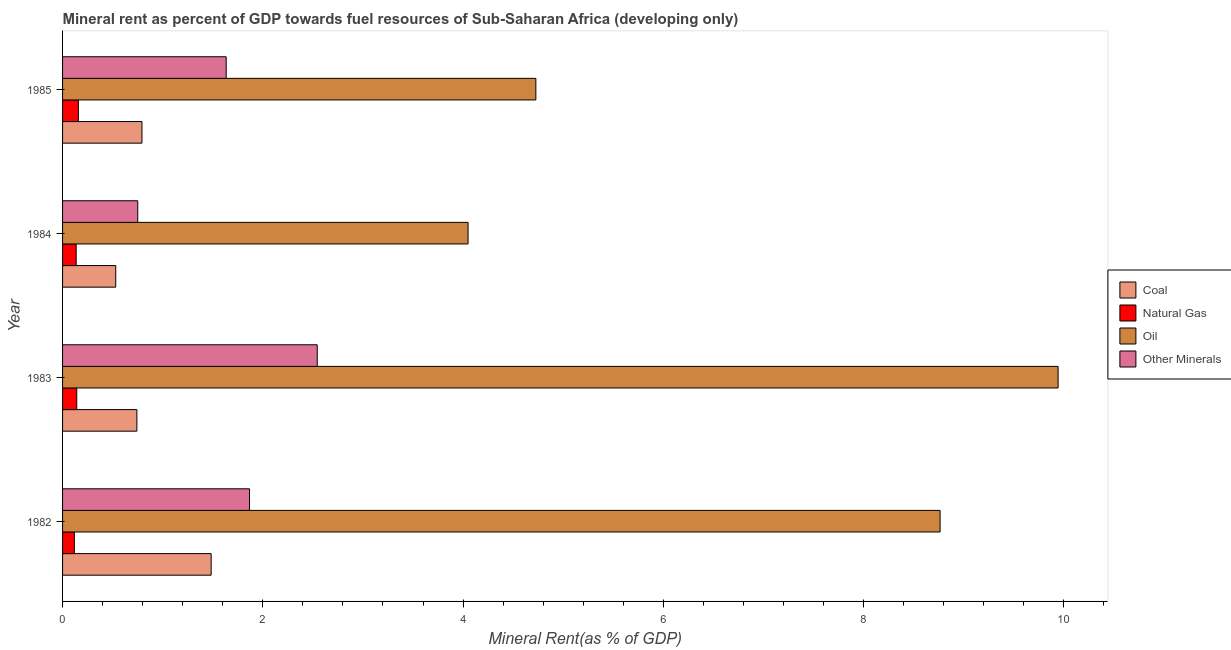How many different coloured bars are there?
Give a very brief answer. 4. How many groups of bars are there?
Offer a terse response. 4. Are the number of bars on each tick of the Y-axis equal?
Make the answer very short. Yes. How many bars are there on the 3rd tick from the top?
Offer a very short reply. 4. What is the label of the 3rd group of bars from the top?
Give a very brief answer. 1983. What is the natural gas rent in 1985?
Keep it short and to the point. 0.16. Across all years, what is the maximum natural gas rent?
Make the answer very short. 0.16. Across all years, what is the minimum  rent of other minerals?
Your answer should be very brief. 0.75. In which year was the natural gas rent maximum?
Make the answer very short. 1985. What is the total coal rent in the graph?
Make the answer very short. 3.55. What is the difference between the coal rent in 1984 and that in 1985?
Give a very brief answer. -0.26. What is the difference between the coal rent in 1985 and the  rent of other minerals in 1983?
Offer a terse response. -1.75. What is the average natural gas rent per year?
Your answer should be compact. 0.14. In the year 1985, what is the difference between the oil rent and natural gas rent?
Your answer should be compact. 4.57. In how many years, is the  rent of other minerals greater than 4 %?
Ensure brevity in your answer.  0. What is the ratio of the  rent of other minerals in 1984 to that in 1985?
Make the answer very short. 0.46. Is the oil rent in 1982 less than that in 1984?
Offer a very short reply. No. What is the difference between the highest and the second highest natural gas rent?
Give a very brief answer. 0.02. What is the difference between the highest and the lowest oil rent?
Offer a very short reply. 5.89. In how many years, is the coal rent greater than the average coal rent taken over all years?
Offer a very short reply. 1. What does the 2nd bar from the top in 1983 represents?
Provide a succinct answer. Oil. What does the 1st bar from the bottom in 1984 represents?
Provide a succinct answer. Coal. Is it the case that in every year, the sum of the coal rent and natural gas rent is greater than the oil rent?
Provide a short and direct response. No. How many years are there in the graph?
Offer a very short reply. 4. Does the graph contain any zero values?
Your answer should be very brief. No. Does the graph contain grids?
Your response must be concise. No. Where does the legend appear in the graph?
Ensure brevity in your answer.  Center right. How many legend labels are there?
Your answer should be compact. 4. What is the title of the graph?
Your answer should be compact. Mineral rent as percent of GDP towards fuel resources of Sub-Saharan Africa (developing only). Does "Oil" appear as one of the legend labels in the graph?
Your answer should be compact. Yes. What is the label or title of the X-axis?
Make the answer very short. Mineral Rent(as % of GDP). What is the Mineral Rent(as % of GDP) in Coal in 1982?
Ensure brevity in your answer.  1.48. What is the Mineral Rent(as % of GDP) in Natural Gas in 1982?
Give a very brief answer. 0.12. What is the Mineral Rent(as % of GDP) in Oil in 1982?
Provide a succinct answer. 8.76. What is the Mineral Rent(as % of GDP) in Other Minerals in 1982?
Offer a terse response. 1.87. What is the Mineral Rent(as % of GDP) of Coal in 1983?
Ensure brevity in your answer.  0.74. What is the Mineral Rent(as % of GDP) of Natural Gas in 1983?
Your response must be concise. 0.14. What is the Mineral Rent(as % of GDP) of Oil in 1983?
Give a very brief answer. 9.94. What is the Mineral Rent(as % of GDP) of Other Minerals in 1983?
Keep it short and to the point. 2.54. What is the Mineral Rent(as % of GDP) in Coal in 1984?
Offer a terse response. 0.53. What is the Mineral Rent(as % of GDP) in Natural Gas in 1984?
Make the answer very short. 0.14. What is the Mineral Rent(as % of GDP) of Oil in 1984?
Your response must be concise. 4.05. What is the Mineral Rent(as % of GDP) in Other Minerals in 1984?
Provide a succinct answer. 0.75. What is the Mineral Rent(as % of GDP) in Coal in 1985?
Make the answer very short. 0.79. What is the Mineral Rent(as % of GDP) of Natural Gas in 1985?
Your answer should be very brief. 0.16. What is the Mineral Rent(as % of GDP) of Oil in 1985?
Offer a very short reply. 4.73. What is the Mineral Rent(as % of GDP) of Other Minerals in 1985?
Your answer should be very brief. 1.63. Across all years, what is the maximum Mineral Rent(as % of GDP) of Coal?
Give a very brief answer. 1.48. Across all years, what is the maximum Mineral Rent(as % of GDP) of Natural Gas?
Offer a very short reply. 0.16. Across all years, what is the maximum Mineral Rent(as % of GDP) of Oil?
Provide a succinct answer. 9.94. Across all years, what is the maximum Mineral Rent(as % of GDP) in Other Minerals?
Offer a very short reply. 2.54. Across all years, what is the minimum Mineral Rent(as % of GDP) of Coal?
Keep it short and to the point. 0.53. Across all years, what is the minimum Mineral Rent(as % of GDP) of Natural Gas?
Offer a terse response. 0.12. Across all years, what is the minimum Mineral Rent(as % of GDP) in Oil?
Your answer should be very brief. 4.05. Across all years, what is the minimum Mineral Rent(as % of GDP) of Other Minerals?
Provide a short and direct response. 0.75. What is the total Mineral Rent(as % of GDP) of Coal in the graph?
Keep it short and to the point. 3.55. What is the total Mineral Rent(as % of GDP) in Natural Gas in the graph?
Provide a short and direct response. 0.55. What is the total Mineral Rent(as % of GDP) of Oil in the graph?
Provide a short and direct response. 27.48. What is the total Mineral Rent(as % of GDP) in Other Minerals in the graph?
Offer a terse response. 6.8. What is the difference between the Mineral Rent(as % of GDP) of Coal in 1982 and that in 1983?
Offer a terse response. 0.74. What is the difference between the Mineral Rent(as % of GDP) of Natural Gas in 1982 and that in 1983?
Your answer should be very brief. -0.02. What is the difference between the Mineral Rent(as % of GDP) of Oil in 1982 and that in 1983?
Your answer should be very brief. -1.18. What is the difference between the Mineral Rent(as % of GDP) of Other Minerals in 1982 and that in 1983?
Provide a succinct answer. -0.68. What is the difference between the Mineral Rent(as % of GDP) of Coal in 1982 and that in 1984?
Make the answer very short. 0.95. What is the difference between the Mineral Rent(as % of GDP) of Natural Gas in 1982 and that in 1984?
Your answer should be compact. -0.02. What is the difference between the Mineral Rent(as % of GDP) in Oil in 1982 and that in 1984?
Offer a very short reply. 4.71. What is the difference between the Mineral Rent(as % of GDP) in Other Minerals in 1982 and that in 1984?
Keep it short and to the point. 1.12. What is the difference between the Mineral Rent(as % of GDP) in Coal in 1982 and that in 1985?
Offer a terse response. 0.69. What is the difference between the Mineral Rent(as % of GDP) of Natural Gas in 1982 and that in 1985?
Your answer should be compact. -0.04. What is the difference between the Mineral Rent(as % of GDP) in Oil in 1982 and that in 1985?
Provide a succinct answer. 4.04. What is the difference between the Mineral Rent(as % of GDP) in Other Minerals in 1982 and that in 1985?
Provide a succinct answer. 0.23. What is the difference between the Mineral Rent(as % of GDP) in Coal in 1983 and that in 1984?
Keep it short and to the point. 0.21. What is the difference between the Mineral Rent(as % of GDP) in Natural Gas in 1983 and that in 1984?
Your answer should be compact. 0.01. What is the difference between the Mineral Rent(as % of GDP) of Oil in 1983 and that in 1984?
Make the answer very short. 5.89. What is the difference between the Mineral Rent(as % of GDP) in Other Minerals in 1983 and that in 1984?
Keep it short and to the point. 1.79. What is the difference between the Mineral Rent(as % of GDP) of Coal in 1983 and that in 1985?
Ensure brevity in your answer.  -0.05. What is the difference between the Mineral Rent(as % of GDP) in Natural Gas in 1983 and that in 1985?
Your answer should be compact. -0.02. What is the difference between the Mineral Rent(as % of GDP) of Oil in 1983 and that in 1985?
Make the answer very short. 5.22. What is the difference between the Mineral Rent(as % of GDP) of Other Minerals in 1983 and that in 1985?
Your response must be concise. 0.91. What is the difference between the Mineral Rent(as % of GDP) of Coal in 1984 and that in 1985?
Provide a short and direct response. -0.26. What is the difference between the Mineral Rent(as % of GDP) in Natural Gas in 1984 and that in 1985?
Offer a very short reply. -0.02. What is the difference between the Mineral Rent(as % of GDP) in Oil in 1984 and that in 1985?
Give a very brief answer. -0.68. What is the difference between the Mineral Rent(as % of GDP) of Other Minerals in 1984 and that in 1985?
Ensure brevity in your answer.  -0.88. What is the difference between the Mineral Rent(as % of GDP) in Coal in 1982 and the Mineral Rent(as % of GDP) in Natural Gas in 1983?
Provide a short and direct response. 1.34. What is the difference between the Mineral Rent(as % of GDP) of Coal in 1982 and the Mineral Rent(as % of GDP) of Oil in 1983?
Ensure brevity in your answer.  -8.46. What is the difference between the Mineral Rent(as % of GDP) in Coal in 1982 and the Mineral Rent(as % of GDP) in Other Minerals in 1983?
Your answer should be very brief. -1.06. What is the difference between the Mineral Rent(as % of GDP) of Natural Gas in 1982 and the Mineral Rent(as % of GDP) of Oil in 1983?
Offer a terse response. -9.82. What is the difference between the Mineral Rent(as % of GDP) in Natural Gas in 1982 and the Mineral Rent(as % of GDP) in Other Minerals in 1983?
Offer a terse response. -2.43. What is the difference between the Mineral Rent(as % of GDP) of Oil in 1982 and the Mineral Rent(as % of GDP) of Other Minerals in 1983?
Your answer should be very brief. 6.22. What is the difference between the Mineral Rent(as % of GDP) of Coal in 1982 and the Mineral Rent(as % of GDP) of Natural Gas in 1984?
Make the answer very short. 1.35. What is the difference between the Mineral Rent(as % of GDP) of Coal in 1982 and the Mineral Rent(as % of GDP) of Oil in 1984?
Ensure brevity in your answer.  -2.57. What is the difference between the Mineral Rent(as % of GDP) of Coal in 1982 and the Mineral Rent(as % of GDP) of Other Minerals in 1984?
Offer a terse response. 0.73. What is the difference between the Mineral Rent(as % of GDP) in Natural Gas in 1982 and the Mineral Rent(as % of GDP) in Oil in 1984?
Offer a very short reply. -3.93. What is the difference between the Mineral Rent(as % of GDP) of Natural Gas in 1982 and the Mineral Rent(as % of GDP) of Other Minerals in 1984?
Offer a very short reply. -0.63. What is the difference between the Mineral Rent(as % of GDP) of Oil in 1982 and the Mineral Rent(as % of GDP) of Other Minerals in 1984?
Keep it short and to the point. 8.01. What is the difference between the Mineral Rent(as % of GDP) in Coal in 1982 and the Mineral Rent(as % of GDP) in Natural Gas in 1985?
Ensure brevity in your answer.  1.33. What is the difference between the Mineral Rent(as % of GDP) of Coal in 1982 and the Mineral Rent(as % of GDP) of Oil in 1985?
Your answer should be very brief. -3.24. What is the difference between the Mineral Rent(as % of GDP) in Coal in 1982 and the Mineral Rent(as % of GDP) in Other Minerals in 1985?
Your answer should be compact. -0.15. What is the difference between the Mineral Rent(as % of GDP) in Natural Gas in 1982 and the Mineral Rent(as % of GDP) in Oil in 1985?
Your answer should be compact. -4.61. What is the difference between the Mineral Rent(as % of GDP) of Natural Gas in 1982 and the Mineral Rent(as % of GDP) of Other Minerals in 1985?
Offer a terse response. -1.52. What is the difference between the Mineral Rent(as % of GDP) in Oil in 1982 and the Mineral Rent(as % of GDP) in Other Minerals in 1985?
Give a very brief answer. 7.13. What is the difference between the Mineral Rent(as % of GDP) in Coal in 1983 and the Mineral Rent(as % of GDP) in Natural Gas in 1984?
Your answer should be compact. 0.61. What is the difference between the Mineral Rent(as % of GDP) in Coal in 1983 and the Mineral Rent(as % of GDP) in Oil in 1984?
Provide a succinct answer. -3.31. What is the difference between the Mineral Rent(as % of GDP) in Coal in 1983 and the Mineral Rent(as % of GDP) in Other Minerals in 1984?
Give a very brief answer. -0.01. What is the difference between the Mineral Rent(as % of GDP) of Natural Gas in 1983 and the Mineral Rent(as % of GDP) of Oil in 1984?
Your response must be concise. -3.91. What is the difference between the Mineral Rent(as % of GDP) in Natural Gas in 1983 and the Mineral Rent(as % of GDP) in Other Minerals in 1984?
Give a very brief answer. -0.61. What is the difference between the Mineral Rent(as % of GDP) of Oil in 1983 and the Mineral Rent(as % of GDP) of Other Minerals in 1984?
Your answer should be compact. 9.19. What is the difference between the Mineral Rent(as % of GDP) of Coal in 1983 and the Mineral Rent(as % of GDP) of Natural Gas in 1985?
Make the answer very short. 0.58. What is the difference between the Mineral Rent(as % of GDP) of Coal in 1983 and the Mineral Rent(as % of GDP) of Oil in 1985?
Make the answer very short. -3.98. What is the difference between the Mineral Rent(as % of GDP) of Coal in 1983 and the Mineral Rent(as % of GDP) of Other Minerals in 1985?
Provide a succinct answer. -0.89. What is the difference between the Mineral Rent(as % of GDP) of Natural Gas in 1983 and the Mineral Rent(as % of GDP) of Oil in 1985?
Give a very brief answer. -4.58. What is the difference between the Mineral Rent(as % of GDP) of Natural Gas in 1983 and the Mineral Rent(as % of GDP) of Other Minerals in 1985?
Your response must be concise. -1.49. What is the difference between the Mineral Rent(as % of GDP) of Oil in 1983 and the Mineral Rent(as % of GDP) of Other Minerals in 1985?
Ensure brevity in your answer.  8.31. What is the difference between the Mineral Rent(as % of GDP) in Coal in 1984 and the Mineral Rent(as % of GDP) in Natural Gas in 1985?
Provide a short and direct response. 0.37. What is the difference between the Mineral Rent(as % of GDP) of Coal in 1984 and the Mineral Rent(as % of GDP) of Oil in 1985?
Give a very brief answer. -4.2. What is the difference between the Mineral Rent(as % of GDP) in Coal in 1984 and the Mineral Rent(as % of GDP) in Other Minerals in 1985?
Provide a succinct answer. -1.1. What is the difference between the Mineral Rent(as % of GDP) of Natural Gas in 1984 and the Mineral Rent(as % of GDP) of Oil in 1985?
Make the answer very short. -4.59. What is the difference between the Mineral Rent(as % of GDP) in Natural Gas in 1984 and the Mineral Rent(as % of GDP) in Other Minerals in 1985?
Offer a very short reply. -1.5. What is the difference between the Mineral Rent(as % of GDP) in Oil in 1984 and the Mineral Rent(as % of GDP) in Other Minerals in 1985?
Offer a terse response. 2.42. What is the average Mineral Rent(as % of GDP) in Coal per year?
Ensure brevity in your answer.  0.89. What is the average Mineral Rent(as % of GDP) in Natural Gas per year?
Your answer should be very brief. 0.14. What is the average Mineral Rent(as % of GDP) in Oil per year?
Give a very brief answer. 6.87. What is the average Mineral Rent(as % of GDP) in Other Minerals per year?
Offer a very short reply. 1.7. In the year 1982, what is the difference between the Mineral Rent(as % of GDP) of Coal and Mineral Rent(as % of GDP) of Natural Gas?
Make the answer very short. 1.37. In the year 1982, what is the difference between the Mineral Rent(as % of GDP) in Coal and Mineral Rent(as % of GDP) in Oil?
Your answer should be compact. -7.28. In the year 1982, what is the difference between the Mineral Rent(as % of GDP) of Coal and Mineral Rent(as % of GDP) of Other Minerals?
Ensure brevity in your answer.  -0.38. In the year 1982, what is the difference between the Mineral Rent(as % of GDP) in Natural Gas and Mineral Rent(as % of GDP) in Oil?
Provide a short and direct response. -8.65. In the year 1982, what is the difference between the Mineral Rent(as % of GDP) of Natural Gas and Mineral Rent(as % of GDP) of Other Minerals?
Give a very brief answer. -1.75. In the year 1982, what is the difference between the Mineral Rent(as % of GDP) of Oil and Mineral Rent(as % of GDP) of Other Minerals?
Your response must be concise. 6.9. In the year 1983, what is the difference between the Mineral Rent(as % of GDP) of Coal and Mineral Rent(as % of GDP) of Natural Gas?
Keep it short and to the point. 0.6. In the year 1983, what is the difference between the Mineral Rent(as % of GDP) in Coal and Mineral Rent(as % of GDP) in Other Minerals?
Provide a short and direct response. -1.8. In the year 1983, what is the difference between the Mineral Rent(as % of GDP) of Natural Gas and Mineral Rent(as % of GDP) of Oil?
Offer a terse response. -9.8. In the year 1983, what is the difference between the Mineral Rent(as % of GDP) of Natural Gas and Mineral Rent(as % of GDP) of Other Minerals?
Keep it short and to the point. -2.4. In the year 1983, what is the difference between the Mineral Rent(as % of GDP) of Oil and Mineral Rent(as % of GDP) of Other Minerals?
Make the answer very short. 7.4. In the year 1984, what is the difference between the Mineral Rent(as % of GDP) of Coal and Mineral Rent(as % of GDP) of Natural Gas?
Give a very brief answer. 0.4. In the year 1984, what is the difference between the Mineral Rent(as % of GDP) in Coal and Mineral Rent(as % of GDP) in Oil?
Your answer should be compact. -3.52. In the year 1984, what is the difference between the Mineral Rent(as % of GDP) in Coal and Mineral Rent(as % of GDP) in Other Minerals?
Your answer should be compact. -0.22. In the year 1984, what is the difference between the Mineral Rent(as % of GDP) of Natural Gas and Mineral Rent(as % of GDP) of Oil?
Provide a short and direct response. -3.91. In the year 1984, what is the difference between the Mineral Rent(as % of GDP) of Natural Gas and Mineral Rent(as % of GDP) of Other Minerals?
Give a very brief answer. -0.61. In the year 1984, what is the difference between the Mineral Rent(as % of GDP) of Oil and Mineral Rent(as % of GDP) of Other Minerals?
Ensure brevity in your answer.  3.3. In the year 1985, what is the difference between the Mineral Rent(as % of GDP) in Coal and Mineral Rent(as % of GDP) in Natural Gas?
Make the answer very short. 0.64. In the year 1985, what is the difference between the Mineral Rent(as % of GDP) in Coal and Mineral Rent(as % of GDP) in Oil?
Give a very brief answer. -3.93. In the year 1985, what is the difference between the Mineral Rent(as % of GDP) in Coal and Mineral Rent(as % of GDP) in Other Minerals?
Your answer should be compact. -0.84. In the year 1985, what is the difference between the Mineral Rent(as % of GDP) of Natural Gas and Mineral Rent(as % of GDP) of Oil?
Provide a short and direct response. -4.57. In the year 1985, what is the difference between the Mineral Rent(as % of GDP) in Natural Gas and Mineral Rent(as % of GDP) in Other Minerals?
Give a very brief answer. -1.48. In the year 1985, what is the difference between the Mineral Rent(as % of GDP) of Oil and Mineral Rent(as % of GDP) of Other Minerals?
Provide a short and direct response. 3.09. What is the ratio of the Mineral Rent(as % of GDP) in Coal in 1982 to that in 1983?
Make the answer very short. 2. What is the ratio of the Mineral Rent(as % of GDP) in Natural Gas in 1982 to that in 1983?
Your answer should be very brief. 0.83. What is the ratio of the Mineral Rent(as % of GDP) in Oil in 1982 to that in 1983?
Offer a very short reply. 0.88. What is the ratio of the Mineral Rent(as % of GDP) of Other Minerals in 1982 to that in 1983?
Make the answer very short. 0.73. What is the ratio of the Mineral Rent(as % of GDP) of Coal in 1982 to that in 1984?
Make the answer very short. 2.79. What is the ratio of the Mineral Rent(as % of GDP) of Natural Gas in 1982 to that in 1984?
Offer a terse response. 0.87. What is the ratio of the Mineral Rent(as % of GDP) in Oil in 1982 to that in 1984?
Make the answer very short. 2.16. What is the ratio of the Mineral Rent(as % of GDP) in Other Minerals in 1982 to that in 1984?
Offer a very short reply. 2.49. What is the ratio of the Mineral Rent(as % of GDP) in Coal in 1982 to that in 1985?
Give a very brief answer. 1.87. What is the ratio of the Mineral Rent(as % of GDP) of Natural Gas in 1982 to that in 1985?
Offer a terse response. 0.75. What is the ratio of the Mineral Rent(as % of GDP) of Oil in 1982 to that in 1985?
Keep it short and to the point. 1.85. What is the ratio of the Mineral Rent(as % of GDP) in Other Minerals in 1982 to that in 1985?
Keep it short and to the point. 1.14. What is the ratio of the Mineral Rent(as % of GDP) of Coal in 1983 to that in 1984?
Give a very brief answer. 1.4. What is the ratio of the Mineral Rent(as % of GDP) in Natural Gas in 1983 to that in 1984?
Keep it short and to the point. 1.04. What is the ratio of the Mineral Rent(as % of GDP) in Oil in 1983 to that in 1984?
Give a very brief answer. 2.46. What is the ratio of the Mineral Rent(as % of GDP) in Other Minerals in 1983 to that in 1984?
Ensure brevity in your answer.  3.39. What is the ratio of the Mineral Rent(as % of GDP) in Coal in 1983 to that in 1985?
Ensure brevity in your answer.  0.94. What is the ratio of the Mineral Rent(as % of GDP) of Natural Gas in 1983 to that in 1985?
Keep it short and to the point. 0.9. What is the ratio of the Mineral Rent(as % of GDP) of Oil in 1983 to that in 1985?
Offer a terse response. 2.1. What is the ratio of the Mineral Rent(as % of GDP) of Other Minerals in 1983 to that in 1985?
Make the answer very short. 1.56. What is the ratio of the Mineral Rent(as % of GDP) of Coal in 1984 to that in 1985?
Provide a short and direct response. 0.67. What is the ratio of the Mineral Rent(as % of GDP) in Natural Gas in 1984 to that in 1985?
Give a very brief answer. 0.86. What is the ratio of the Mineral Rent(as % of GDP) in Oil in 1984 to that in 1985?
Your response must be concise. 0.86. What is the ratio of the Mineral Rent(as % of GDP) of Other Minerals in 1984 to that in 1985?
Give a very brief answer. 0.46. What is the difference between the highest and the second highest Mineral Rent(as % of GDP) of Coal?
Keep it short and to the point. 0.69. What is the difference between the highest and the second highest Mineral Rent(as % of GDP) in Natural Gas?
Your answer should be very brief. 0.02. What is the difference between the highest and the second highest Mineral Rent(as % of GDP) of Oil?
Provide a succinct answer. 1.18. What is the difference between the highest and the second highest Mineral Rent(as % of GDP) in Other Minerals?
Keep it short and to the point. 0.68. What is the difference between the highest and the lowest Mineral Rent(as % of GDP) in Coal?
Provide a short and direct response. 0.95. What is the difference between the highest and the lowest Mineral Rent(as % of GDP) of Natural Gas?
Your answer should be compact. 0.04. What is the difference between the highest and the lowest Mineral Rent(as % of GDP) in Oil?
Your answer should be very brief. 5.89. What is the difference between the highest and the lowest Mineral Rent(as % of GDP) of Other Minerals?
Your answer should be compact. 1.79. 